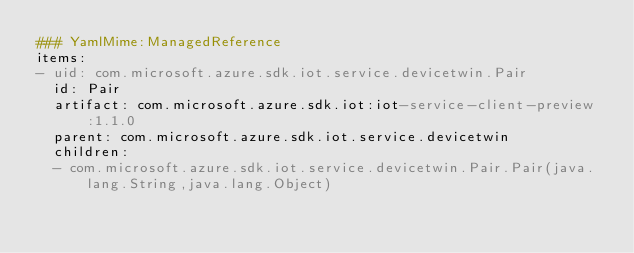<code> <loc_0><loc_0><loc_500><loc_500><_YAML_>### YamlMime:ManagedReference
items:
- uid: com.microsoft.azure.sdk.iot.service.devicetwin.Pair
  id: Pair
  artifact: com.microsoft.azure.sdk.iot:iot-service-client-preview:1.1.0
  parent: com.microsoft.azure.sdk.iot.service.devicetwin
  children:
  - com.microsoft.azure.sdk.iot.service.devicetwin.Pair.Pair(java.lang.String,java.lang.Object)</code> 